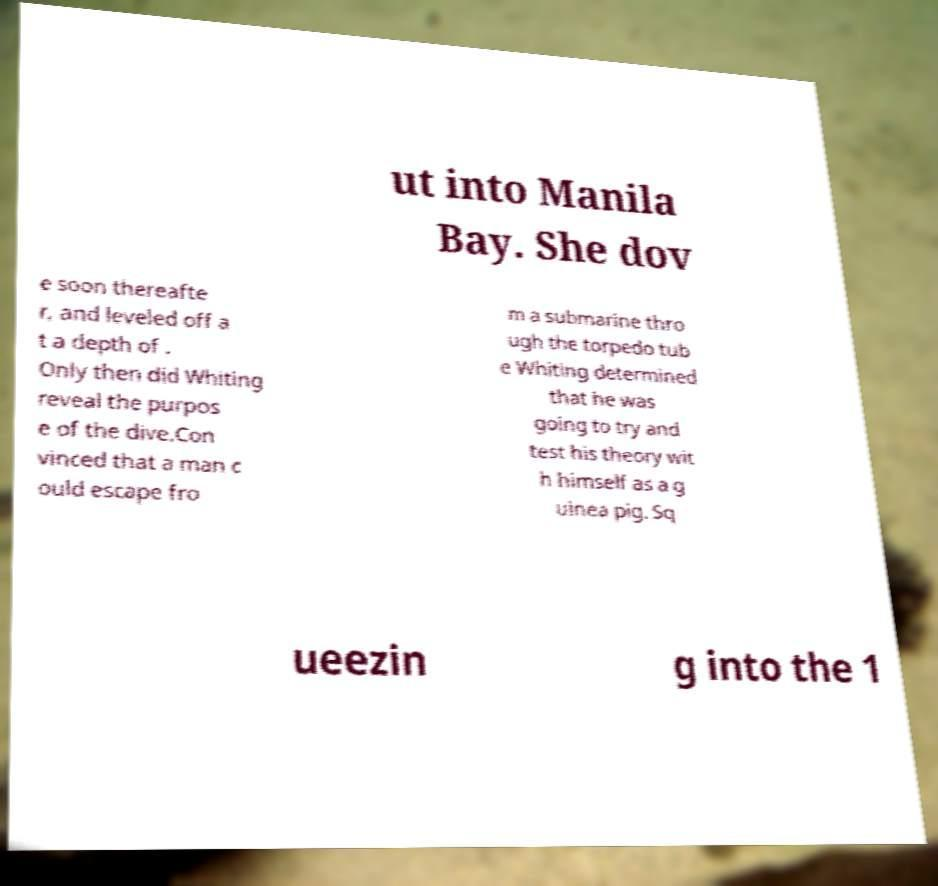I need the written content from this picture converted into text. Can you do that? ut into Manila Bay. She dov e soon thereafte r, and leveled off a t a depth of . Only then did Whiting reveal the purpos e of the dive.Con vinced that a man c ould escape fro m a submarine thro ugh the torpedo tub e Whiting determined that he was going to try and test his theory wit h himself as a g uinea pig. Sq ueezin g into the 1 